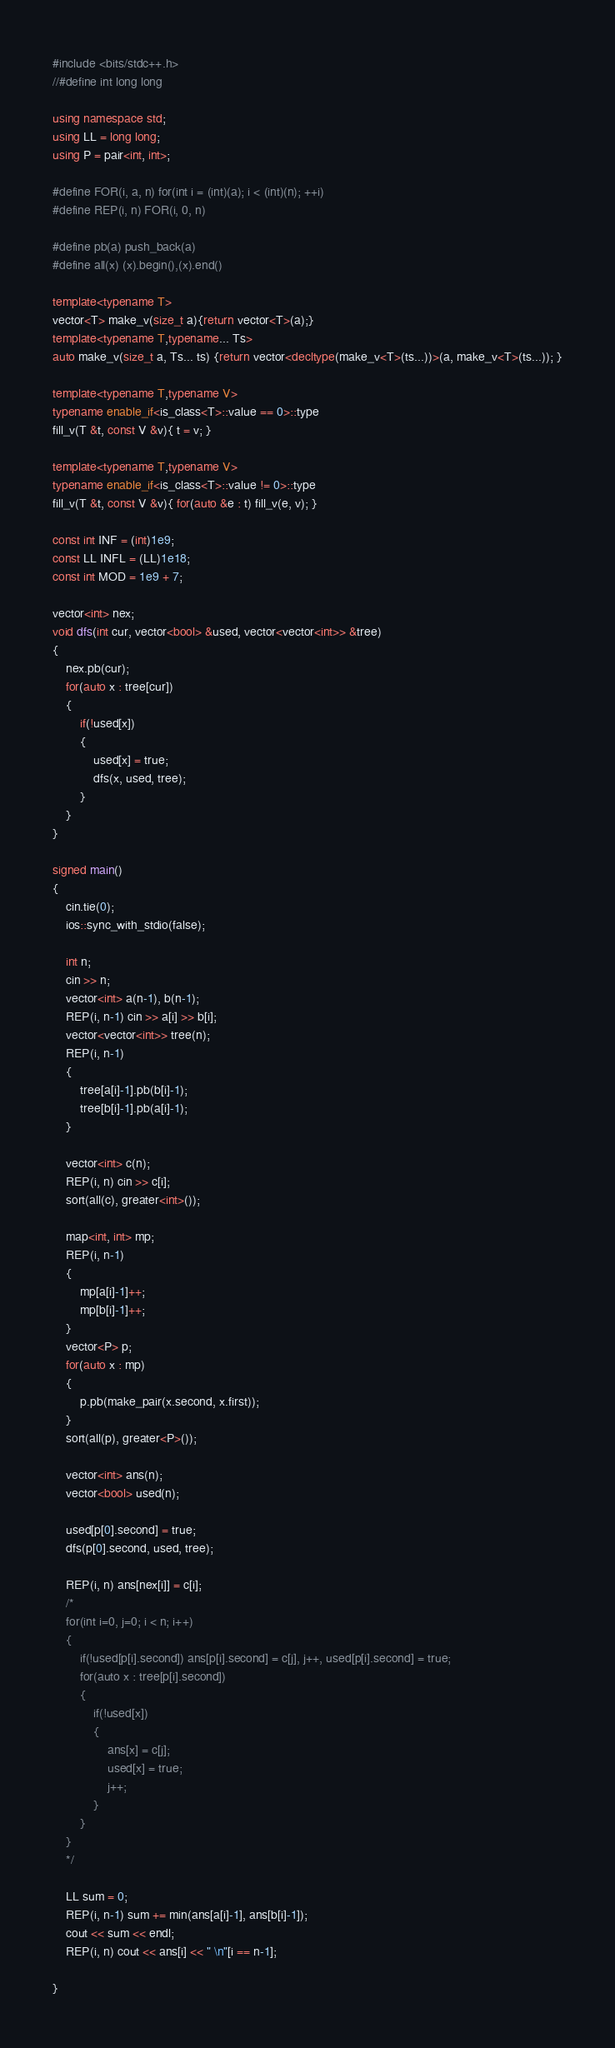Convert code to text. <code><loc_0><loc_0><loc_500><loc_500><_C++_>#include <bits/stdc++.h>
//#define int long long

using namespace std;
using LL = long long;
using P = pair<int, int>;

#define FOR(i, a, n) for(int i = (int)(a); i < (int)(n); ++i)
#define REP(i, n) FOR(i, 0, n)

#define pb(a) push_back(a)
#define all(x) (x).begin(),(x).end()

template<typename T>
vector<T> make_v(size_t a){return vector<T>(a);}
template<typename T,typename... Ts>
auto make_v(size_t a, Ts... ts) {return vector<decltype(make_v<T>(ts...))>(a, make_v<T>(ts...)); }

template<typename T,typename V>
typename enable_if<is_class<T>::value == 0>::type
fill_v(T &t, const V &v){ t = v; }

template<typename T,typename V>
typename enable_if<is_class<T>::value != 0>::type
fill_v(T &t, const V &v){ for(auto &e : t) fill_v(e, v); }

const int INF = (int)1e9;
const LL INFL = (LL)1e18;
const int MOD = 1e9 + 7;

vector<int> nex;
void dfs(int cur, vector<bool> &used, vector<vector<int>> &tree)
{
    nex.pb(cur);
    for(auto x : tree[cur])
    {
        if(!used[x])
        {
            used[x] = true;
            dfs(x, used, tree);
        }
    }
}

signed main()
{
    cin.tie(0);
    ios::sync_with_stdio(false);
    
    int n;
    cin >> n;
    vector<int> a(n-1), b(n-1);
    REP(i, n-1) cin >> a[i] >> b[i];
    vector<vector<int>> tree(n);
    REP(i, n-1)
    {
        tree[a[i]-1].pb(b[i]-1);
        tree[b[i]-1].pb(a[i]-1);
    }

    vector<int> c(n);
    REP(i, n) cin >> c[i];
    sort(all(c), greater<int>());

    map<int, int> mp;
    REP(i, n-1)
    {
        mp[a[i]-1]++;
        mp[b[i]-1]++;
    }
    vector<P> p;
    for(auto x : mp)
    {
        p.pb(make_pair(x.second, x.first));
    }
    sort(all(p), greater<P>());
    
    vector<int> ans(n);
    vector<bool> used(n);

    used[p[0].second] = true;
    dfs(p[0].second, used, tree);

    REP(i, n) ans[nex[i]] = c[i];
    /*
    for(int i=0, j=0; i < n; i++)
    {
        if(!used[p[i].second]) ans[p[i].second] = c[j], j++, used[p[i].second] = true;
        for(auto x : tree[p[i].second])
        {
            if(!used[x])
            {
                ans[x] = c[j];
                used[x] = true;
                j++;
            }
        }
    }
    */

    LL sum = 0;
    REP(i, n-1) sum += min(ans[a[i]-1], ans[b[i]-1]);
    cout << sum << endl; 
    REP(i, n) cout << ans[i] << " \n"[i == n-1];

}</code> 